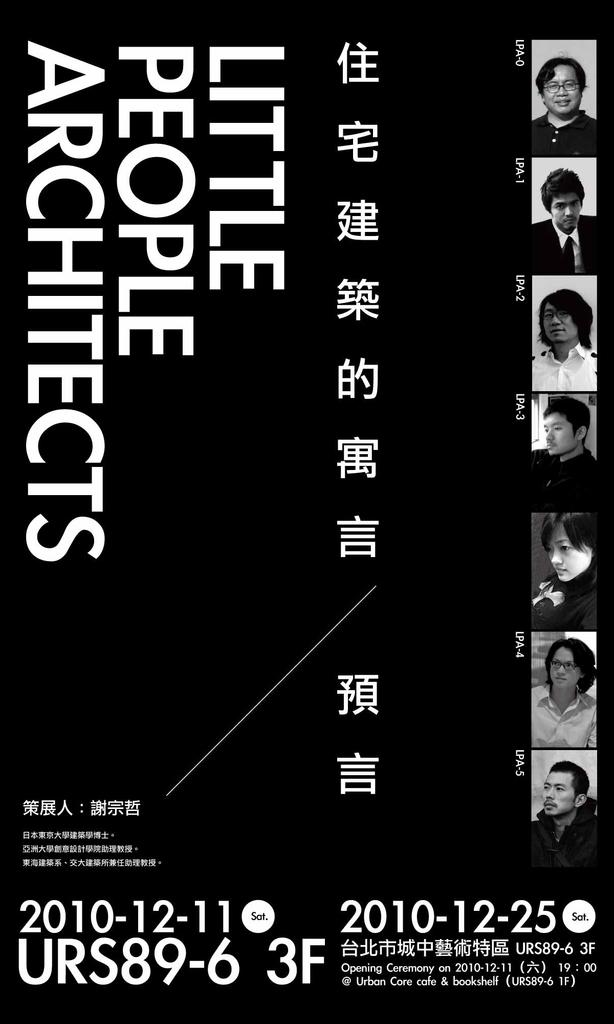Provide a one-sentence caption for the provided image. An advertisement mostly in Chinese called little people architects. 